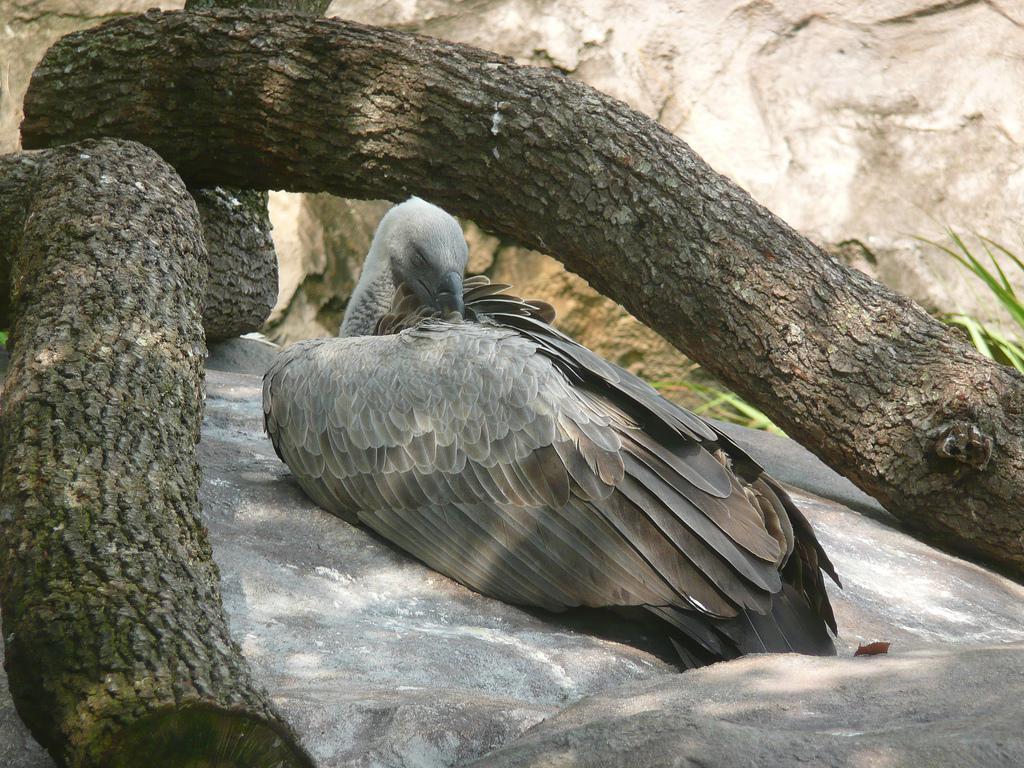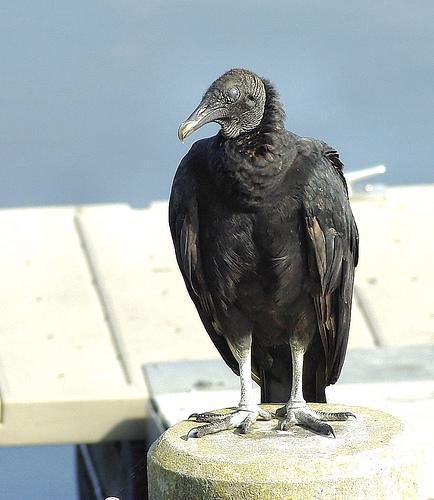The first image is the image on the left, the second image is the image on the right. For the images displayed, is the sentence "One of the birds is perched in a tree branch." factually correct? Answer yes or no. No. The first image is the image on the left, the second image is the image on the right. Analyze the images presented: Is the assertion "In one of the images the bird is perched on a large branch." valid? Answer yes or no. No. 